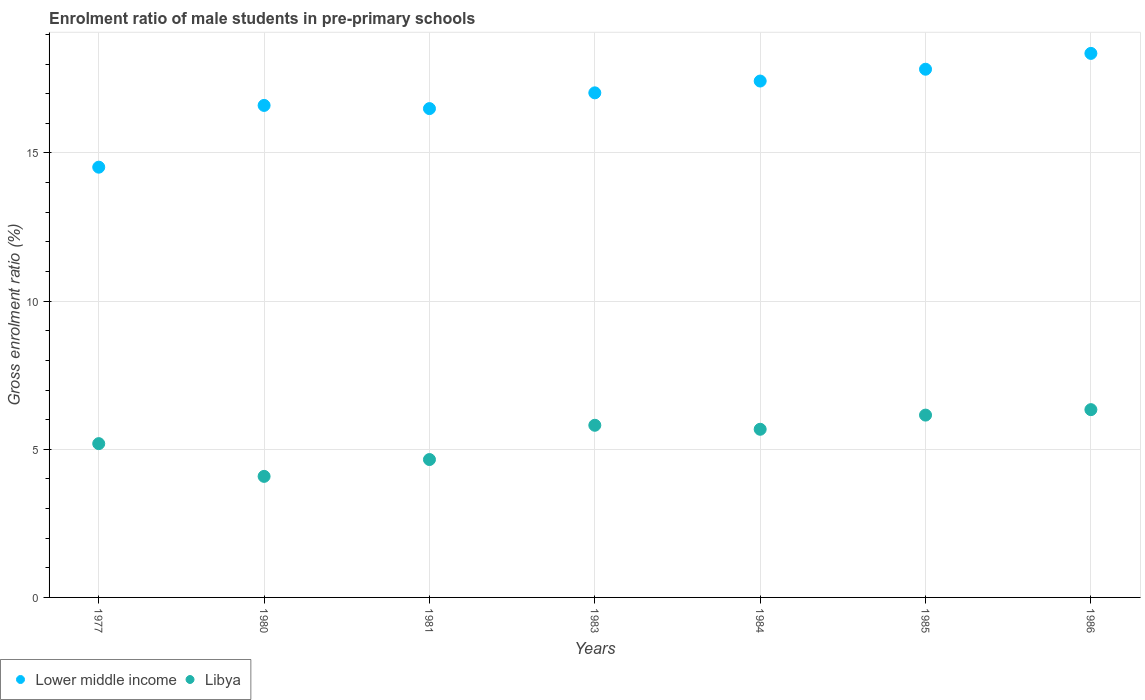How many different coloured dotlines are there?
Provide a short and direct response. 2. Is the number of dotlines equal to the number of legend labels?
Offer a very short reply. Yes. What is the enrolment ratio of male students in pre-primary schools in Libya in 1984?
Provide a short and direct response. 5.67. Across all years, what is the maximum enrolment ratio of male students in pre-primary schools in Libya?
Offer a terse response. 6.34. Across all years, what is the minimum enrolment ratio of male students in pre-primary schools in Lower middle income?
Give a very brief answer. 14.52. In which year was the enrolment ratio of male students in pre-primary schools in Libya minimum?
Your answer should be compact. 1980. What is the total enrolment ratio of male students in pre-primary schools in Lower middle income in the graph?
Provide a short and direct response. 118.26. What is the difference between the enrolment ratio of male students in pre-primary schools in Libya in 1981 and that in 1986?
Your response must be concise. -1.68. What is the difference between the enrolment ratio of male students in pre-primary schools in Libya in 1983 and the enrolment ratio of male students in pre-primary schools in Lower middle income in 1981?
Your answer should be very brief. -10.69. What is the average enrolment ratio of male students in pre-primary schools in Lower middle income per year?
Provide a short and direct response. 16.89. In the year 1980, what is the difference between the enrolment ratio of male students in pre-primary schools in Lower middle income and enrolment ratio of male students in pre-primary schools in Libya?
Offer a terse response. 12.52. What is the ratio of the enrolment ratio of male students in pre-primary schools in Lower middle income in 1983 to that in 1984?
Ensure brevity in your answer.  0.98. Is the enrolment ratio of male students in pre-primary schools in Libya in 1980 less than that in 1983?
Your answer should be very brief. Yes. Is the difference between the enrolment ratio of male students in pre-primary schools in Lower middle income in 1977 and 1984 greater than the difference between the enrolment ratio of male students in pre-primary schools in Libya in 1977 and 1984?
Offer a very short reply. No. What is the difference between the highest and the second highest enrolment ratio of male students in pre-primary schools in Lower middle income?
Offer a terse response. 0.53. What is the difference between the highest and the lowest enrolment ratio of male students in pre-primary schools in Lower middle income?
Keep it short and to the point. 3.84. Does the enrolment ratio of male students in pre-primary schools in Libya monotonically increase over the years?
Offer a terse response. No. Is the enrolment ratio of male students in pre-primary schools in Lower middle income strictly greater than the enrolment ratio of male students in pre-primary schools in Libya over the years?
Provide a short and direct response. Yes. Is the enrolment ratio of male students in pre-primary schools in Libya strictly less than the enrolment ratio of male students in pre-primary schools in Lower middle income over the years?
Make the answer very short. Yes. What is the difference between two consecutive major ticks on the Y-axis?
Your answer should be very brief. 5. Are the values on the major ticks of Y-axis written in scientific E-notation?
Provide a succinct answer. No. Does the graph contain grids?
Your answer should be compact. Yes. How many legend labels are there?
Provide a short and direct response. 2. What is the title of the graph?
Offer a very short reply. Enrolment ratio of male students in pre-primary schools. What is the label or title of the X-axis?
Your answer should be compact. Years. What is the Gross enrolment ratio (%) of Lower middle income in 1977?
Make the answer very short. 14.52. What is the Gross enrolment ratio (%) in Libya in 1977?
Offer a very short reply. 5.19. What is the Gross enrolment ratio (%) in Lower middle income in 1980?
Your response must be concise. 16.6. What is the Gross enrolment ratio (%) in Libya in 1980?
Keep it short and to the point. 4.09. What is the Gross enrolment ratio (%) in Lower middle income in 1981?
Provide a succinct answer. 16.5. What is the Gross enrolment ratio (%) of Libya in 1981?
Your answer should be compact. 4.65. What is the Gross enrolment ratio (%) in Lower middle income in 1983?
Ensure brevity in your answer.  17.03. What is the Gross enrolment ratio (%) of Libya in 1983?
Give a very brief answer. 5.81. What is the Gross enrolment ratio (%) of Lower middle income in 1984?
Give a very brief answer. 17.43. What is the Gross enrolment ratio (%) of Libya in 1984?
Provide a succinct answer. 5.67. What is the Gross enrolment ratio (%) in Lower middle income in 1985?
Give a very brief answer. 17.83. What is the Gross enrolment ratio (%) of Libya in 1985?
Provide a short and direct response. 6.15. What is the Gross enrolment ratio (%) in Lower middle income in 1986?
Ensure brevity in your answer.  18.36. What is the Gross enrolment ratio (%) in Libya in 1986?
Your response must be concise. 6.34. Across all years, what is the maximum Gross enrolment ratio (%) in Lower middle income?
Keep it short and to the point. 18.36. Across all years, what is the maximum Gross enrolment ratio (%) of Libya?
Ensure brevity in your answer.  6.34. Across all years, what is the minimum Gross enrolment ratio (%) of Lower middle income?
Keep it short and to the point. 14.52. Across all years, what is the minimum Gross enrolment ratio (%) of Libya?
Your response must be concise. 4.09. What is the total Gross enrolment ratio (%) of Lower middle income in the graph?
Give a very brief answer. 118.26. What is the total Gross enrolment ratio (%) of Libya in the graph?
Your answer should be compact. 37.9. What is the difference between the Gross enrolment ratio (%) in Lower middle income in 1977 and that in 1980?
Your answer should be compact. -2.08. What is the difference between the Gross enrolment ratio (%) in Libya in 1977 and that in 1980?
Offer a terse response. 1.1. What is the difference between the Gross enrolment ratio (%) of Lower middle income in 1977 and that in 1981?
Offer a very short reply. -1.98. What is the difference between the Gross enrolment ratio (%) of Libya in 1977 and that in 1981?
Offer a terse response. 0.54. What is the difference between the Gross enrolment ratio (%) in Lower middle income in 1977 and that in 1983?
Make the answer very short. -2.51. What is the difference between the Gross enrolment ratio (%) in Libya in 1977 and that in 1983?
Your answer should be very brief. -0.62. What is the difference between the Gross enrolment ratio (%) of Lower middle income in 1977 and that in 1984?
Give a very brief answer. -2.91. What is the difference between the Gross enrolment ratio (%) in Libya in 1977 and that in 1984?
Provide a succinct answer. -0.48. What is the difference between the Gross enrolment ratio (%) in Lower middle income in 1977 and that in 1985?
Keep it short and to the point. -3.31. What is the difference between the Gross enrolment ratio (%) in Libya in 1977 and that in 1985?
Offer a very short reply. -0.96. What is the difference between the Gross enrolment ratio (%) in Lower middle income in 1977 and that in 1986?
Offer a very short reply. -3.84. What is the difference between the Gross enrolment ratio (%) in Libya in 1977 and that in 1986?
Make the answer very short. -1.15. What is the difference between the Gross enrolment ratio (%) of Lower middle income in 1980 and that in 1981?
Offer a very short reply. 0.11. What is the difference between the Gross enrolment ratio (%) of Libya in 1980 and that in 1981?
Offer a terse response. -0.57. What is the difference between the Gross enrolment ratio (%) in Lower middle income in 1980 and that in 1983?
Offer a very short reply. -0.42. What is the difference between the Gross enrolment ratio (%) in Libya in 1980 and that in 1983?
Provide a succinct answer. -1.72. What is the difference between the Gross enrolment ratio (%) of Lower middle income in 1980 and that in 1984?
Provide a short and direct response. -0.82. What is the difference between the Gross enrolment ratio (%) in Libya in 1980 and that in 1984?
Your answer should be very brief. -1.59. What is the difference between the Gross enrolment ratio (%) in Lower middle income in 1980 and that in 1985?
Offer a very short reply. -1.22. What is the difference between the Gross enrolment ratio (%) in Libya in 1980 and that in 1985?
Your answer should be very brief. -2.07. What is the difference between the Gross enrolment ratio (%) of Lower middle income in 1980 and that in 1986?
Offer a very short reply. -1.76. What is the difference between the Gross enrolment ratio (%) of Libya in 1980 and that in 1986?
Make the answer very short. -2.25. What is the difference between the Gross enrolment ratio (%) of Lower middle income in 1981 and that in 1983?
Ensure brevity in your answer.  -0.53. What is the difference between the Gross enrolment ratio (%) of Libya in 1981 and that in 1983?
Provide a short and direct response. -1.16. What is the difference between the Gross enrolment ratio (%) in Lower middle income in 1981 and that in 1984?
Offer a very short reply. -0.93. What is the difference between the Gross enrolment ratio (%) of Libya in 1981 and that in 1984?
Offer a terse response. -1.02. What is the difference between the Gross enrolment ratio (%) in Lower middle income in 1981 and that in 1985?
Your answer should be very brief. -1.33. What is the difference between the Gross enrolment ratio (%) in Libya in 1981 and that in 1985?
Your answer should be compact. -1.5. What is the difference between the Gross enrolment ratio (%) in Lower middle income in 1981 and that in 1986?
Make the answer very short. -1.86. What is the difference between the Gross enrolment ratio (%) of Libya in 1981 and that in 1986?
Your response must be concise. -1.68. What is the difference between the Gross enrolment ratio (%) of Lower middle income in 1983 and that in 1984?
Your answer should be compact. -0.4. What is the difference between the Gross enrolment ratio (%) of Libya in 1983 and that in 1984?
Offer a terse response. 0.14. What is the difference between the Gross enrolment ratio (%) of Lower middle income in 1983 and that in 1985?
Ensure brevity in your answer.  -0.8. What is the difference between the Gross enrolment ratio (%) of Libya in 1983 and that in 1985?
Provide a short and direct response. -0.34. What is the difference between the Gross enrolment ratio (%) of Lower middle income in 1983 and that in 1986?
Your answer should be very brief. -1.33. What is the difference between the Gross enrolment ratio (%) in Libya in 1983 and that in 1986?
Your answer should be compact. -0.53. What is the difference between the Gross enrolment ratio (%) of Lower middle income in 1984 and that in 1985?
Provide a succinct answer. -0.4. What is the difference between the Gross enrolment ratio (%) in Libya in 1984 and that in 1985?
Give a very brief answer. -0.48. What is the difference between the Gross enrolment ratio (%) in Lower middle income in 1984 and that in 1986?
Your response must be concise. -0.93. What is the difference between the Gross enrolment ratio (%) of Libya in 1984 and that in 1986?
Your answer should be compact. -0.66. What is the difference between the Gross enrolment ratio (%) in Lower middle income in 1985 and that in 1986?
Offer a terse response. -0.53. What is the difference between the Gross enrolment ratio (%) of Libya in 1985 and that in 1986?
Your response must be concise. -0.18. What is the difference between the Gross enrolment ratio (%) in Lower middle income in 1977 and the Gross enrolment ratio (%) in Libya in 1980?
Your response must be concise. 10.43. What is the difference between the Gross enrolment ratio (%) of Lower middle income in 1977 and the Gross enrolment ratio (%) of Libya in 1981?
Your answer should be compact. 9.87. What is the difference between the Gross enrolment ratio (%) of Lower middle income in 1977 and the Gross enrolment ratio (%) of Libya in 1983?
Give a very brief answer. 8.71. What is the difference between the Gross enrolment ratio (%) in Lower middle income in 1977 and the Gross enrolment ratio (%) in Libya in 1984?
Your answer should be compact. 8.85. What is the difference between the Gross enrolment ratio (%) in Lower middle income in 1977 and the Gross enrolment ratio (%) in Libya in 1985?
Provide a short and direct response. 8.37. What is the difference between the Gross enrolment ratio (%) of Lower middle income in 1977 and the Gross enrolment ratio (%) of Libya in 1986?
Your answer should be compact. 8.18. What is the difference between the Gross enrolment ratio (%) of Lower middle income in 1980 and the Gross enrolment ratio (%) of Libya in 1981?
Your response must be concise. 11.95. What is the difference between the Gross enrolment ratio (%) in Lower middle income in 1980 and the Gross enrolment ratio (%) in Libya in 1983?
Provide a succinct answer. 10.79. What is the difference between the Gross enrolment ratio (%) in Lower middle income in 1980 and the Gross enrolment ratio (%) in Libya in 1984?
Keep it short and to the point. 10.93. What is the difference between the Gross enrolment ratio (%) of Lower middle income in 1980 and the Gross enrolment ratio (%) of Libya in 1985?
Offer a terse response. 10.45. What is the difference between the Gross enrolment ratio (%) in Lower middle income in 1980 and the Gross enrolment ratio (%) in Libya in 1986?
Make the answer very short. 10.27. What is the difference between the Gross enrolment ratio (%) of Lower middle income in 1981 and the Gross enrolment ratio (%) of Libya in 1983?
Keep it short and to the point. 10.69. What is the difference between the Gross enrolment ratio (%) in Lower middle income in 1981 and the Gross enrolment ratio (%) in Libya in 1984?
Provide a succinct answer. 10.82. What is the difference between the Gross enrolment ratio (%) of Lower middle income in 1981 and the Gross enrolment ratio (%) of Libya in 1985?
Keep it short and to the point. 10.34. What is the difference between the Gross enrolment ratio (%) in Lower middle income in 1981 and the Gross enrolment ratio (%) in Libya in 1986?
Your answer should be compact. 10.16. What is the difference between the Gross enrolment ratio (%) of Lower middle income in 1983 and the Gross enrolment ratio (%) of Libya in 1984?
Your answer should be compact. 11.35. What is the difference between the Gross enrolment ratio (%) of Lower middle income in 1983 and the Gross enrolment ratio (%) of Libya in 1985?
Your answer should be very brief. 10.88. What is the difference between the Gross enrolment ratio (%) in Lower middle income in 1983 and the Gross enrolment ratio (%) in Libya in 1986?
Give a very brief answer. 10.69. What is the difference between the Gross enrolment ratio (%) of Lower middle income in 1984 and the Gross enrolment ratio (%) of Libya in 1985?
Ensure brevity in your answer.  11.27. What is the difference between the Gross enrolment ratio (%) in Lower middle income in 1984 and the Gross enrolment ratio (%) in Libya in 1986?
Your response must be concise. 11.09. What is the difference between the Gross enrolment ratio (%) in Lower middle income in 1985 and the Gross enrolment ratio (%) in Libya in 1986?
Keep it short and to the point. 11.49. What is the average Gross enrolment ratio (%) of Lower middle income per year?
Provide a short and direct response. 16.89. What is the average Gross enrolment ratio (%) in Libya per year?
Provide a short and direct response. 5.41. In the year 1977, what is the difference between the Gross enrolment ratio (%) in Lower middle income and Gross enrolment ratio (%) in Libya?
Make the answer very short. 9.33. In the year 1980, what is the difference between the Gross enrolment ratio (%) in Lower middle income and Gross enrolment ratio (%) in Libya?
Provide a succinct answer. 12.52. In the year 1981, what is the difference between the Gross enrolment ratio (%) of Lower middle income and Gross enrolment ratio (%) of Libya?
Your answer should be very brief. 11.84. In the year 1983, what is the difference between the Gross enrolment ratio (%) of Lower middle income and Gross enrolment ratio (%) of Libya?
Offer a very short reply. 11.22. In the year 1984, what is the difference between the Gross enrolment ratio (%) in Lower middle income and Gross enrolment ratio (%) in Libya?
Keep it short and to the point. 11.75. In the year 1985, what is the difference between the Gross enrolment ratio (%) of Lower middle income and Gross enrolment ratio (%) of Libya?
Provide a succinct answer. 11.67. In the year 1986, what is the difference between the Gross enrolment ratio (%) of Lower middle income and Gross enrolment ratio (%) of Libya?
Make the answer very short. 12.02. What is the ratio of the Gross enrolment ratio (%) of Lower middle income in 1977 to that in 1980?
Ensure brevity in your answer.  0.87. What is the ratio of the Gross enrolment ratio (%) of Libya in 1977 to that in 1980?
Your response must be concise. 1.27. What is the ratio of the Gross enrolment ratio (%) of Lower middle income in 1977 to that in 1981?
Give a very brief answer. 0.88. What is the ratio of the Gross enrolment ratio (%) of Libya in 1977 to that in 1981?
Offer a very short reply. 1.12. What is the ratio of the Gross enrolment ratio (%) in Lower middle income in 1977 to that in 1983?
Your answer should be compact. 0.85. What is the ratio of the Gross enrolment ratio (%) of Libya in 1977 to that in 1983?
Your answer should be compact. 0.89. What is the ratio of the Gross enrolment ratio (%) in Lower middle income in 1977 to that in 1984?
Ensure brevity in your answer.  0.83. What is the ratio of the Gross enrolment ratio (%) in Libya in 1977 to that in 1984?
Provide a succinct answer. 0.91. What is the ratio of the Gross enrolment ratio (%) of Lower middle income in 1977 to that in 1985?
Keep it short and to the point. 0.81. What is the ratio of the Gross enrolment ratio (%) of Libya in 1977 to that in 1985?
Make the answer very short. 0.84. What is the ratio of the Gross enrolment ratio (%) in Lower middle income in 1977 to that in 1986?
Offer a terse response. 0.79. What is the ratio of the Gross enrolment ratio (%) of Libya in 1977 to that in 1986?
Ensure brevity in your answer.  0.82. What is the ratio of the Gross enrolment ratio (%) of Lower middle income in 1980 to that in 1981?
Your answer should be very brief. 1.01. What is the ratio of the Gross enrolment ratio (%) of Libya in 1980 to that in 1981?
Give a very brief answer. 0.88. What is the ratio of the Gross enrolment ratio (%) in Lower middle income in 1980 to that in 1983?
Offer a very short reply. 0.98. What is the ratio of the Gross enrolment ratio (%) in Libya in 1980 to that in 1983?
Keep it short and to the point. 0.7. What is the ratio of the Gross enrolment ratio (%) of Lower middle income in 1980 to that in 1984?
Provide a short and direct response. 0.95. What is the ratio of the Gross enrolment ratio (%) in Libya in 1980 to that in 1984?
Your answer should be very brief. 0.72. What is the ratio of the Gross enrolment ratio (%) of Lower middle income in 1980 to that in 1985?
Provide a succinct answer. 0.93. What is the ratio of the Gross enrolment ratio (%) of Libya in 1980 to that in 1985?
Your answer should be very brief. 0.66. What is the ratio of the Gross enrolment ratio (%) of Lower middle income in 1980 to that in 1986?
Keep it short and to the point. 0.9. What is the ratio of the Gross enrolment ratio (%) of Libya in 1980 to that in 1986?
Your answer should be very brief. 0.64. What is the ratio of the Gross enrolment ratio (%) of Lower middle income in 1981 to that in 1983?
Your answer should be compact. 0.97. What is the ratio of the Gross enrolment ratio (%) of Libya in 1981 to that in 1983?
Your answer should be very brief. 0.8. What is the ratio of the Gross enrolment ratio (%) in Lower middle income in 1981 to that in 1984?
Your answer should be very brief. 0.95. What is the ratio of the Gross enrolment ratio (%) in Libya in 1981 to that in 1984?
Keep it short and to the point. 0.82. What is the ratio of the Gross enrolment ratio (%) in Lower middle income in 1981 to that in 1985?
Your answer should be compact. 0.93. What is the ratio of the Gross enrolment ratio (%) in Libya in 1981 to that in 1985?
Ensure brevity in your answer.  0.76. What is the ratio of the Gross enrolment ratio (%) in Lower middle income in 1981 to that in 1986?
Ensure brevity in your answer.  0.9. What is the ratio of the Gross enrolment ratio (%) in Libya in 1981 to that in 1986?
Give a very brief answer. 0.73. What is the ratio of the Gross enrolment ratio (%) of Lower middle income in 1983 to that in 1984?
Ensure brevity in your answer.  0.98. What is the ratio of the Gross enrolment ratio (%) of Libya in 1983 to that in 1984?
Offer a very short reply. 1.02. What is the ratio of the Gross enrolment ratio (%) of Lower middle income in 1983 to that in 1985?
Your response must be concise. 0.96. What is the ratio of the Gross enrolment ratio (%) in Libya in 1983 to that in 1985?
Provide a short and direct response. 0.94. What is the ratio of the Gross enrolment ratio (%) in Lower middle income in 1983 to that in 1986?
Provide a short and direct response. 0.93. What is the ratio of the Gross enrolment ratio (%) in Libya in 1983 to that in 1986?
Offer a terse response. 0.92. What is the ratio of the Gross enrolment ratio (%) in Lower middle income in 1984 to that in 1985?
Offer a terse response. 0.98. What is the ratio of the Gross enrolment ratio (%) in Libya in 1984 to that in 1985?
Your answer should be very brief. 0.92. What is the ratio of the Gross enrolment ratio (%) in Lower middle income in 1984 to that in 1986?
Ensure brevity in your answer.  0.95. What is the ratio of the Gross enrolment ratio (%) of Libya in 1984 to that in 1986?
Make the answer very short. 0.9. What is the ratio of the Gross enrolment ratio (%) in Lower middle income in 1985 to that in 1986?
Your response must be concise. 0.97. What is the ratio of the Gross enrolment ratio (%) of Libya in 1985 to that in 1986?
Keep it short and to the point. 0.97. What is the difference between the highest and the second highest Gross enrolment ratio (%) in Lower middle income?
Make the answer very short. 0.53. What is the difference between the highest and the second highest Gross enrolment ratio (%) in Libya?
Ensure brevity in your answer.  0.18. What is the difference between the highest and the lowest Gross enrolment ratio (%) of Lower middle income?
Provide a short and direct response. 3.84. What is the difference between the highest and the lowest Gross enrolment ratio (%) in Libya?
Make the answer very short. 2.25. 